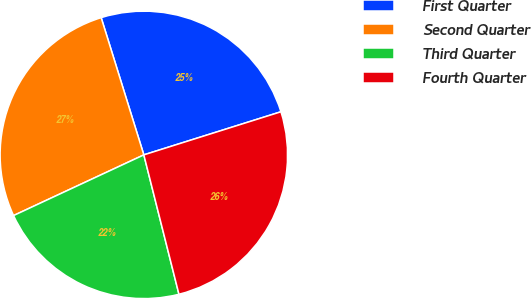<chart> <loc_0><loc_0><loc_500><loc_500><pie_chart><fcel>First Quarter<fcel>Second Quarter<fcel>Third Quarter<fcel>Fourth Quarter<nl><fcel>24.95%<fcel>27.14%<fcel>21.99%<fcel>25.92%<nl></chart> 